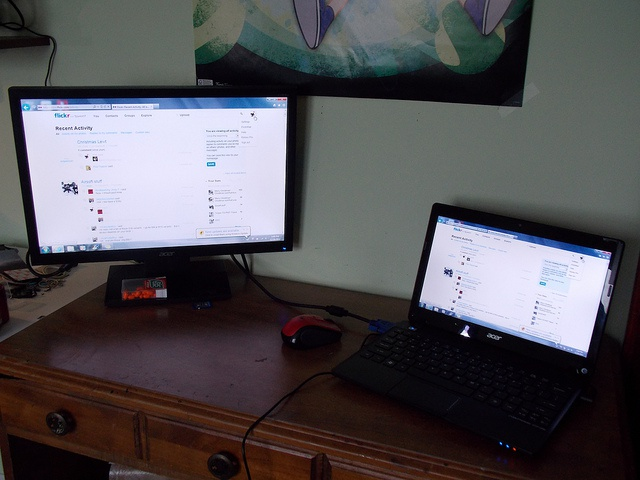Describe the objects in this image and their specific colors. I can see tv in black, lavender, darkgray, and blue tones, laptop in black, lavender, darkgray, and blue tones, and mouse in black, maroon, and gray tones in this image. 